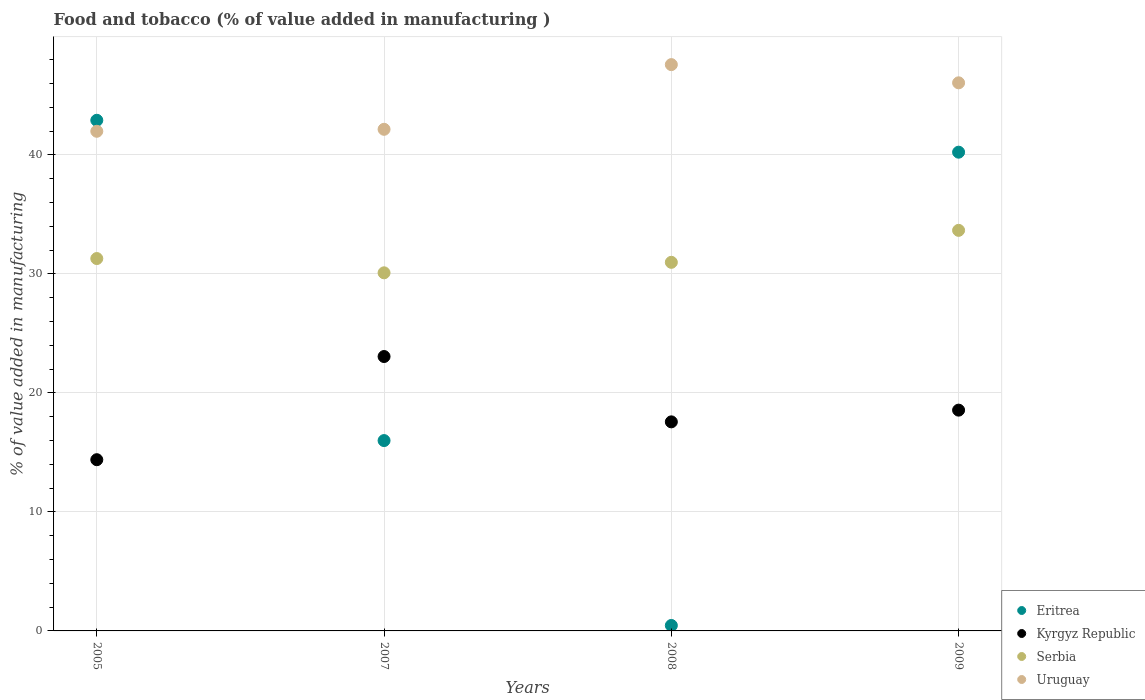What is the value added in manufacturing food and tobacco in Kyrgyz Republic in 2008?
Your answer should be compact. 17.57. Across all years, what is the maximum value added in manufacturing food and tobacco in Uruguay?
Offer a terse response. 47.59. Across all years, what is the minimum value added in manufacturing food and tobacco in Serbia?
Offer a very short reply. 30.09. In which year was the value added in manufacturing food and tobacco in Uruguay minimum?
Your response must be concise. 2005. What is the total value added in manufacturing food and tobacco in Uruguay in the graph?
Ensure brevity in your answer.  177.79. What is the difference between the value added in manufacturing food and tobacco in Uruguay in 2005 and that in 2007?
Your answer should be very brief. -0.17. What is the difference between the value added in manufacturing food and tobacco in Kyrgyz Republic in 2007 and the value added in manufacturing food and tobacco in Eritrea in 2008?
Your answer should be very brief. 22.6. What is the average value added in manufacturing food and tobacco in Serbia per year?
Make the answer very short. 31.51. In the year 2005, what is the difference between the value added in manufacturing food and tobacco in Kyrgyz Republic and value added in manufacturing food and tobacco in Serbia?
Offer a terse response. -16.9. In how many years, is the value added in manufacturing food and tobacco in Uruguay greater than 34 %?
Keep it short and to the point. 4. What is the ratio of the value added in manufacturing food and tobacco in Uruguay in 2007 to that in 2008?
Your response must be concise. 0.89. Is the value added in manufacturing food and tobacco in Serbia in 2007 less than that in 2008?
Provide a short and direct response. Yes. Is the difference between the value added in manufacturing food and tobacco in Kyrgyz Republic in 2005 and 2009 greater than the difference between the value added in manufacturing food and tobacco in Serbia in 2005 and 2009?
Make the answer very short. No. What is the difference between the highest and the second highest value added in manufacturing food and tobacco in Serbia?
Your answer should be very brief. 2.37. What is the difference between the highest and the lowest value added in manufacturing food and tobacco in Eritrea?
Keep it short and to the point. 42.45. Is the sum of the value added in manufacturing food and tobacco in Serbia in 2005 and 2007 greater than the maximum value added in manufacturing food and tobacco in Uruguay across all years?
Your answer should be compact. Yes. Does the value added in manufacturing food and tobacco in Kyrgyz Republic monotonically increase over the years?
Give a very brief answer. No. Is the value added in manufacturing food and tobacco in Eritrea strictly greater than the value added in manufacturing food and tobacco in Kyrgyz Republic over the years?
Offer a very short reply. No. What is the difference between two consecutive major ticks on the Y-axis?
Your answer should be very brief. 10. Are the values on the major ticks of Y-axis written in scientific E-notation?
Offer a terse response. No. Does the graph contain any zero values?
Your response must be concise. No. Does the graph contain grids?
Make the answer very short. Yes. Where does the legend appear in the graph?
Make the answer very short. Bottom right. How many legend labels are there?
Make the answer very short. 4. How are the legend labels stacked?
Offer a terse response. Vertical. What is the title of the graph?
Keep it short and to the point. Food and tobacco (% of value added in manufacturing ). Does "Greenland" appear as one of the legend labels in the graph?
Your response must be concise. No. What is the label or title of the Y-axis?
Keep it short and to the point. % of value added in manufacturing. What is the % of value added in manufacturing of Eritrea in 2005?
Your answer should be very brief. 42.91. What is the % of value added in manufacturing in Kyrgyz Republic in 2005?
Your answer should be compact. 14.39. What is the % of value added in manufacturing in Serbia in 2005?
Your answer should be very brief. 31.29. What is the % of value added in manufacturing in Uruguay in 2005?
Offer a terse response. 41.99. What is the % of value added in manufacturing in Eritrea in 2007?
Your answer should be compact. 16. What is the % of value added in manufacturing of Kyrgyz Republic in 2007?
Your answer should be very brief. 23.06. What is the % of value added in manufacturing of Serbia in 2007?
Ensure brevity in your answer.  30.09. What is the % of value added in manufacturing in Uruguay in 2007?
Keep it short and to the point. 42.15. What is the % of value added in manufacturing of Eritrea in 2008?
Your response must be concise. 0.46. What is the % of value added in manufacturing in Kyrgyz Republic in 2008?
Your response must be concise. 17.57. What is the % of value added in manufacturing in Serbia in 2008?
Offer a very short reply. 30.97. What is the % of value added in manufacturing in Uruguay in 2008?
Provide a succinct answer. 47.59. What is the % of value added in manufacturing in Eritrea in 2009?
Your response must be concise. 40.23. What is the % of value added in manufacturing of Kyrgyz Republic in 2009?
Offer a terse response. 18.55. What is the % of value added in manufacturing of Serbia in 2009?
Your answer should be compact. 33.66. What is the % of value added in manufacturing of Uruguay in 2009?
Your answer should be very brief. 46.06. Across all years, what is the maximum % of value added in manufacturing in Eritrea?
Offer a terse response. 42.91. Across all years, what is the maximum % of value added in manufacturing in Kyrgyz Republic?
Offer a very short reply. 23.06. Across all years, what is the maximum % of value added in manufacturing of Serbia?
Make the answer very short. 33.66. Across all years, what is the maximum % of value added in manufacturing of Uruguay?
Your response must be concise. 47.59. Across all years, what is the minimum % of value added in manufacturing of Eritrea?
Offer a very short reply. 0.46. Across all years, what is the minimum % of value added in manufacturing in Kyrgyz Republic?
Give a very brief answer. 14.39. Across all years, what is the minimum % of value added in manufacturing of Serbia?
Keep it short and to the point. 30.09. Across all years, what is the minimum % of value added in manufacturing in Uruguay?
Your response must be concise. 41.99. What is the total % of value added in manufacturing in Eritrea in the graph?
Your answer should be compact. 99.59. What is the total % of value added in manufacturing of Kyrgyz Republic in the graph?
Your response must be concise. 73.57. What is the total % of value added in manufacturing of Serbia in the graph?
Keep it short and to the point. 126.02. What is the total % of value added in manufacturing of Uruguay in the graph?
Your response must be concise. 177.79. What is the difference between the % of value added in manufacturing of Eritrea in 2005 and that in 2007?
Ensure brevity in your answer.  26.92. What is the difference between the % of value added in manufacturing of Kyrgyz Republic in 2005 and that in 2007?
Provide a short and direct response. -8.67. What is the difference between the % of value added in manufacturing in Serbia in 2005 and that in 2007?
Offer a terse response. 1.2. What is the difference between the % of value added in manufacturing of Uruguay in 2005 and that in 2007?
Give a very brief answer. -0.17. What is the difference between the % of value added in manufacturing in Eritrea in 2005 and that in 2008?
Ensure brevity in your answer.  42.45. What is the difference between the % of value added in manufacturing of Kyrgyz Republic in 2005 and that in 2008?
Keep it short and to the point. -3.18. What is the difference between the % of value added in manufacturing in Serbia in 2005 and that in 2008?
Make the answer very short. 0.32. What is the difference between the % of value added in manufacturing of Uruguay in 2005 and that in 2008?
Your answer should be very brief. -5.6. What is the difference between the % of value added in manufacturing in Eritrea in 2005 and that in 2009?
Your response must be concise. 2.68. What is the difference between the % of value added in manufacturing of Kyrgyz Republic in 2005 and that in 2009?
Your answer should be very brief. -4.16. What is the difference between the % of value added in manufacturing of Serbia in 2005 and that in 2009?
Make the answer very short. -2.37. What is the difference between the % of value added in manufacturing in Uruguay in 2005 and that in 2009?
Offer a terse response. -4.07. What is the difference between the % of value added in manufacturing of Eritrea in 2007 and that in 2008?
Your answer should be compact. 15.54. What is the difference between the % of value added in manufacturing of Kyrgyz Republic in 2007 and that in 2008?
Offer a very short reply. 5.49. What is the difference between the % of value added in manufacturing in Serbia in 2007 and that in 2008?
Keep it short and to the point. -0.88. What is the difference between the % of value added in manufacturing in Uruguay in 2007 and that in 2008?
Offer a very short reply. -5.44. What is the difference between the % of value added in manufacturing of Eritrea in 2007 and that in 2009?
Your answer should be compact. -24.23. What is the difference between the % of value added in manufacturing of Kyrgyz Republic in 2007 and that in 2009?
Offer a terse response. 4.51. What is the difference between the % of value added in manufacturing of Serbia in 2007 and that in 2009?
Your response must be concise. -3.57. What is the difference between the % of value added in manufacturing of Uruguay in 2007 and that in 2009?
Offer a very short reply. -3.91. What is the difference between the % of value added in manufacturing of Eritrea in 2008 and that in 2009?
Your answer should be very brief. -39.77. What is the difference between the % of value added in manufacturing in Kyrgyz Republic in 2008 and that in 2009?
Offer a very short reply. -0.98. What is the difference between the % of value added in manufacturing of Serbia in 2008 and that in 2009?
Offer a terse response. -2.69. What is the difference between the % of value added in manufacturing in Uruguay in 2008 and that in 2009?
Your response must be concise. 1.53. What is the difference between the % of value added in manufacturing of Eritrea in 2005 and the % of value added in manufacturing of Kyrgyz Republic in 2007?
Keep it short and to the point. 19.85. What is the difference between the % of value added in manufacturing of Eritrea in 2005 and the % of value added in manufacturing of Serbia in 2007?
Keep it short and to the point. 12.82. What is the difference between the % of value added in manufacturing of Eritrea in 2005 and the % of value added in manufacturing of Uruguay in 2007?
Keep it short and to the point. 0.76. What is the difference between the % of value added in manufacturing in Kyrgyz Republic in 2005 and the % of value added in manufacturing in Serbia in 2007?
Your answer should be compact. -15.7. What is the difference between the % of value added in manufacturing in Kyrgyz Republic in 2005 and the % of value added in manufacturing in Uruguay in 2007?
Your answer should be very brief. -27.76. What is the difference between the % of value added in manufacturing in Serbia in 2005 and the % of value added in manufacturing in Uruguay in 2007?
Provide a succinct answer. -10.86. What is the difference between the % of value added in manufacturing of Eritrea in 2005 and the % of value added in manufacturing of Kyrgyz Republic in 2008?
Provide a short and direct response. 25.34. What is the difference between the % of value added in manufacturing in Eritrea in 2005 and the % of value added in manufacturing in Serbia in 2008?
Give a very brief answer. 11.94. What is the difference between the % of value added in manufacturing in Eritrea in 2005 and the % of value added in manufacturing in Uruguay in 2008?
Your answer should be compact. -4.68. What is the difference between the % of value added in manufacturing in Kyrgyz Republic in 2005 and the % of value added in manufacturing in Serbia in 2008?
Keep it short and to the point. -16.59. What is the difference between the % of value added in manufacturing in Kyrgyz Republic in 2005 and the % of value added in manufacturing in Uruguay in 2008?
Provide a succinct answer. -33.2. What is the difference between the % of value added in manufacturing of Serbia in 2005 and the % of value added in manufacturing of Uruguay in 2008?
Your answer should be very brief. -16.3. What is the difference between the % of value added in manufacturing in Eritrea in 2005 and the % of value added in manufacturing in Kyrgyz Republic in 2009?
Your response must be concise. 24.36. What is the difference between the % of value added in manufacturing in Eritrea in 2005 and the % of value added in manufacturing in Serbia in 2009?
Keep it short and to the point. 9.25. What is the difference between the % of value added in manufacturing of Eritrea in 2005 and the % of value added in manufacturing of Uruguay in 2009?
Ensure brevity in your answer.  -3.15. What is the difference between the % of value added in manufacturing of Kyrgyz Republic in 2005 and the % of value added in manufacturing of Serbia in 2009?
Give a very brief answer. -19.27. What is the difference between the % of value added in manufacturing in Kyrgyz Republic in 2005 and the % of value added in manufacturing in Uruguay in 2009?
Provide a short and direct response. -31.67. What is the difference between the % of value added in manufacturing in Serbia in 2005 and the % of value added in manufacturing in Uruguay in 2009?
Your response must be concise. -14.77. What is the difference between the % of value added in manufacturing in Eritrea in 2007 and the % of value added in manufacturing in Kyrgyz Republic in 2008?
Provide a short and direct response. -1.57. What is the difference between the % of value added in manufacturing of Eritrea in 2007 and the % of value added in manufacturing of Serbia in 2008?
Ensure brevity in your answer.  -14.98. What is the difference between the % of value added in manufacturing in Eritrea in 2007 and the % of value added in manufacturing in Uruguay in 2008?
Make the answer very short. -31.59. What is the difference between the % of value added in manufacturing of Kyrgyz Republic in 2007 and the % of value added in manufacturing of Serbia in 2008?
Your answer should be compact. -7.92. What is the difference between the % of value added in manufacturing of Kyrgyz Republic in 2007 and the % of value added in manufacturing of Uruguay in 2008?
Give a very brief answer. -24.53. What is the difference between the % of value added in manufacturing in Serbia in 2007 and the % of value added in manufacturing in Uruguay in 2008?
Ensure brevity in your answer.  -17.5. What is the difference between the % of value added in manufacturing in Eritrea in 2007 and the % of value added in manufacturing in Kyrgyz Republic in 2009?
Keep it short and to the point. -2.56. What is the difference between the % of value added in manufacturing of Eritrea in 2007 and the % of value added in manufacturing of Serbia in 2009?
Your response must be concise. -17.67. What is the difference between the % of value added in manufacturing of Eritrea in 2007 and the % of value added in manufacturing of Uruguay in 2009?
Make the answer very short. -30.06. What is the difference between the % of value added in manufacturing in Kyrgyz Republic in 2007 and the % of value added in manufacturing in Serbia in 2009?
Ensure brevity in your answer.  -10.6. What is the difference between the % of value added in manufacturing of Kyrgyz Republic in 2007 and the % of value added in manufacturing of Uruguay in 2009?
Offer a terse response. -23. What is the difference between the % of value added in manufacturing in Serbia in 2007 and the % of value added in manufacturing in Uruguay in 2009?
Make the answer very short. -15.97. What is the difference between the % of value added in manufacturing in Eritrea in 2008 and the % of value added in manufacturing in Kyrgyz Republic in 2009?
Keep it short and to the point. -18.1. What is the difference between the % of value added in manufacturing in Eritrea in 2008 and the % of value added in manufacturing in Serbia in 2009?
Your response must be concise. -33.2. What is the difference between the % of value added in manufacturing in Eritrea in 2008 and the % of value added in manufacturing in Uruguay in 2009?
Provide a short and direct response. -45.6. What is the difference between the % of value added in manufacturing in Kyrgyz Republic in 2008 and the % of value added in manufacturing in Serbia in 2009?
Offer a terse response. -16.09. What is the difference between the % of value added in manufacturing in Kyrgyz Republic in 2008 and the % of value added in manufacturing in Uruguay in 2009?
Offer a very short reply. -28.49. What is the difference between the % of value added in manufacturing of Serbia in 2008 and the % of value added in manufacturing of Uruguay in 2009?
Give a very brief answer. -15.08. What is the average % of value added in manufacturing in Eritrea per year?
Offer a terse response. 24.9. What is the average % of value added in manufacturing in Kyrgyz Republic per year?
Ensure brevity in your answer.  18.39. What is the average % of value added in manufacturing of Serbia per year?
Offer a very short reply. 31.51. What is the average % of value added in manufacturing of Uruguay per year?
Provide a short and direct response. 44.45. In the year 2005, what is the difference between the % of value added in manufacturing in Eritrea and % of value added in manufacturing in Kyrgyz Republic?
Provide a short and direct response. 28.52. In the year 2005, what is the difference between the % of value added in manufacturing in Eritrea and % of value added in manufacturing in Serbia?
Your answer should be compact. 11.62. In the year 2005, what is the difference between the % of value added in manufacturing of Eritrea and % of value added in manufacturing of Uruguay?
Offer a very short reply. 0.92. In the year 2005, what is the difference between the % of value added in manufacturing in Kyrgyz Republic and % of value added in manufacturing in Serbia?
Keep it short and to the point. -16.9. In the year 2005, what is the difference between the % of value added in manufacturing of Kyrgyz Republic and % of value added in manufacturing of Uruguay?
Give a very brief answer. -27.6. In the year 2005, what is the difference between the % of value added in manufacturing in Serbia and % of value added in manufacturing in Uruguay?
Ensure brevity in your answer.  -10.69. In the year 2007, what is the difference between the % of value added in manufacturing of Eritrea and % of value added in manufacturing of Kyrgyz Republic?
Offer a very short reply. -7.06. In the year 2007, what is the difference between the % of value added in manufacturing in Eritrea and % of value added in manufacturing in Serbia?
Offer a terse response. -14.1. In the year 2007, what is the difference between the % of value added in manufacturing in Eritrea and % of value added in manufacturing in Uruguay?
Offer a very short reply. -26.16. In the year 2007, what is the difference between the % of value added in manufacturing in Kyrgyz Republic and % of value added in manufacturing in Serbia?
Your response must be concise. -7.03. In the year 2007, what is the difference between the % of value added in manufacturing of Kyrgyz Republic and % of value added in manufacturing of Uruguay?
Ensure brevity in your answer.  -19.09. In the year 2007, what is the difference between the % of value added in manufacturing in Serbia and % of value added in manufacturing in Uruguay?
Provide a succinct answer. -12.06. In the year 2008, what is the difference between the % of value added in manufacturing of Eritrea and % of value added in manufacturing of Kyrgyz Republic?
Provide a succinct answer. -17.11. In the year 2008, what is the difference between the % of value added in manufacturing of Eritrea and % of value added in manufacturing of Serbia?
Provide a succinct answer. -30.52. In the year 2008, what is the difference between the % of value added in manufacturing in Eritrea and % of value added in manufacturing in Uruguay?
Provide a short and direct response. -47.13. In the year 2008, what is the difference between the % of value added in manufacturing of Kyrgyz Republic and % of value added in manufacturing of Serbia?
Give a very brief answer. -13.41. In the year 2008, what is the difference between the % of value added in manufacturing in Kyrgyz Republic and % of value added in manufacturing in Uruguay?
Make the answer very short. -30.02. In the year 2008, what is the difference between the % of value added in manufacturing of Serbia and % of value added in manufacturing of Uruguay?
Keep it short and to the point. -16.61. In the year 2009, what is the difference between the % of value added in manufacturing of Eritrea and % of value added in manufacturing of Kyrgyz Republic?
Provide a short and direct response. 21.68. In the year 2009, what is the difference between the % of value added in manufacturing of Eritrea and % of value added in manufacturing of Serbia?
Provide a short and direct response. 6.57. In the year 2009, what is the difference between the % of value added in manufacturing of Eritrea and % of value added in manufacturing of Uruguay?
Provide a short and direct response. -5.83. In the year 2009, what is the difference between the % of value added in manufacturing of Kyrgyz Republic and % of value added in manufacturing of Serbia?
Give a very brief answer. -15.11. In the year 2009, what is the difference between the % of value added in manufacturing in Kyrgyz Republic and % of value added in manufacturing in Uruguay?
Your answer should be compact. -27.51. In the year 2009, what is the difference between the % of value added in manufacturing of Serbia and % of value added in manufacturing of Uruguay?
Your answer should be very brief. -12.4. What is the ratio of the % of value added in manufacturing of Eritrea in 2005 to that in 2007?
Your answer should be compact. 2.68. What is the ratio of the % of value added in manufacturing in Kyrgyz Republic in 2005 to that in 2007?
Make the answer very short. 0.62. What is the ratio of the % of value added in manufacturing of Serbia in 2005 to that in 2007?
Give a very brief answer. 1.04. What is the ratio of the % of value added in manufacturing in Uruguay in 2005 to that in 2007?
Make the answer very short. 1. What is the ratio of the % of value added in manufacturing in Eritrea in 2005 to that in 2008?
Your answer should be compact. 93.71. What is the ratio of the % of value added in manufacturing in Kyrgyz Republic in 2005 to that in 2008?
Offer a terse response. 0.82. What is the ratio of the % of value added in manufacturing in Serbia in 2005 to that in 2008?
Provide a succinct answer. 1.01. What is the ratio of the % of value added in manufacturing of Uruguay in 2005 to that in 2008?
Ensure brevity in your answer.  0.88. What is the ratio of the % of value added in manufacturing of Eritrea in 2005 to that in 2009?
Your response must be concise. 1.07. What is the ratio of the % of value added in manufacturing in Kyrgyz Republic in 2005 to that in 2009?
Give a very brief answer. 0.78. What is the ratio of the % of value added in manufacturing in Serbia in 2005 to that in 2009?
Provide a succinct answer. 0.93. What is the ratio of the % of value added in manufacturing in Uruguay in 2005 to that in 2009?
Your answer should be compact. 0.91. What is the ratio of the % of value added in manufacturing of Eritrea in 2007 to that in 2008?
Provide a succinct answer. 34.93. What is the ratio of the % of value added in manufacturing of Kyrgyz Republic in 2007 to that in 2008?
Offer a very short reply. 1.31. What is the ratio of the % of value added in manufacturing in Serbia in 2007 to that in 2008?
Provide a succinct answer. 0.97. What is the ratio of the % of value added in manufacturing in Uruguay in 2007 to that in 2008?
Ensure brevity in your answer.  0.89. What is the ratio of the % of value added in manufacturing of Eritrea in 2007 to that in 2009?
Provide a succinct answer. 0.4. What is the ratio of the % of value added in manufacturing in Kyrgyz Republic in 2007 to that in 2009?
Your answer should be compact. 1.24. What is the ratio of the % of value added in manufacturing of Serbia in 2007 to that in 2009?
Provide a short and direct response. 0.89. What is the ratio of the % of value added in manufacturing of Uruguay in 2007 to that in 2009?
Offer a terse response. 0.92. What is the ratio of the % of value added in manufacturing in Eritrea in 2008 to that in 2009?
Your response must be concise. 0.01. What is the ratio of the % of value added in manufacturing in Kyrgyz Republic in 2008 to that in 2009?
Your response must be concise. 0.95. What is the ratio of the % of value added in manufacturing in Serbia in 2008 to that in 2009?
Your answer should be very brief. 0.92. What is the ratio of the % of value added in manufacturing in Uruguay in 2008 to that in 2009?
Provide a short and direct response. 1.03. What is the difference between the highest and the second highest % of value added in manufacturing of Eritrea?
Make the answer very short. 2.68. What is the difference between the highest and the second highest % of value added in manufacturing in Kyrgyz Republic?
Your answer should be very brief. 4.51. What is the difference between the highest and the second highest % of value added in manufacturing of Serbia?
Your answer should be very brief. 2.37. What is the difference between the highest and the second highest % of value added in manufacturing in Uruguay?
Keep it short and to the point. 1.53. What is the difference between the highest and the lowest % of value added in manufacturing of Eritrea?
Provide a succinct answer. 42.45. What is the difference between the highest and the lowest % of value added in manufacturing in Kyrgyz Republic?
Offer a terse response. 8.67. What is the difference between the highest and the lowest % of value added in manufacturing of Serbia?
Provide a succinct answer. 3.57. What is the difference between the highest and the lowest % of value added in manufacturing in Uruguay?
Provide a short and direct response. 5.6. 